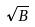<formula> <loc_0><loc_0><loc_500><loc_500>\sqrt { B }</formula> 